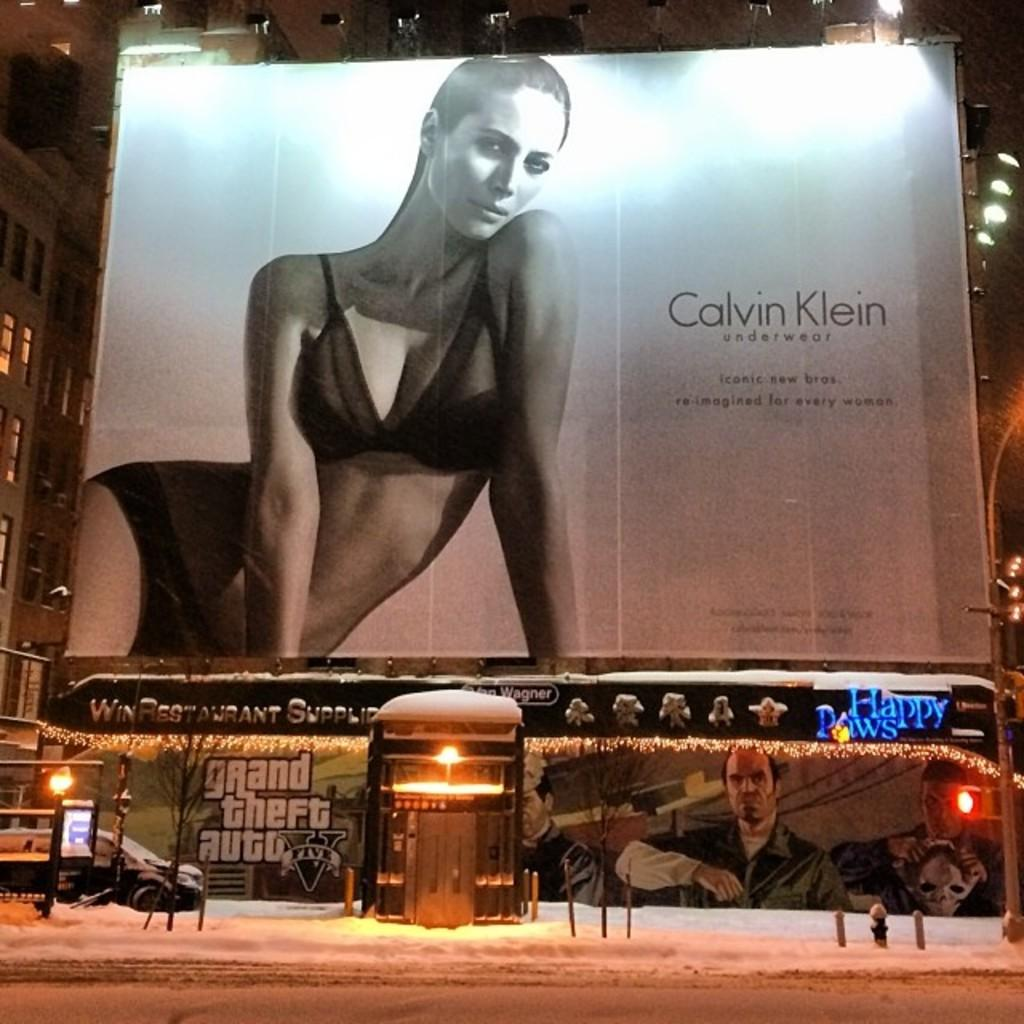<image>
Share a concise interpretation of the image provided. A large Calvin Klein ad on a wall featuring a woman in a swimsuit, right above a banner for grand theft auto. 